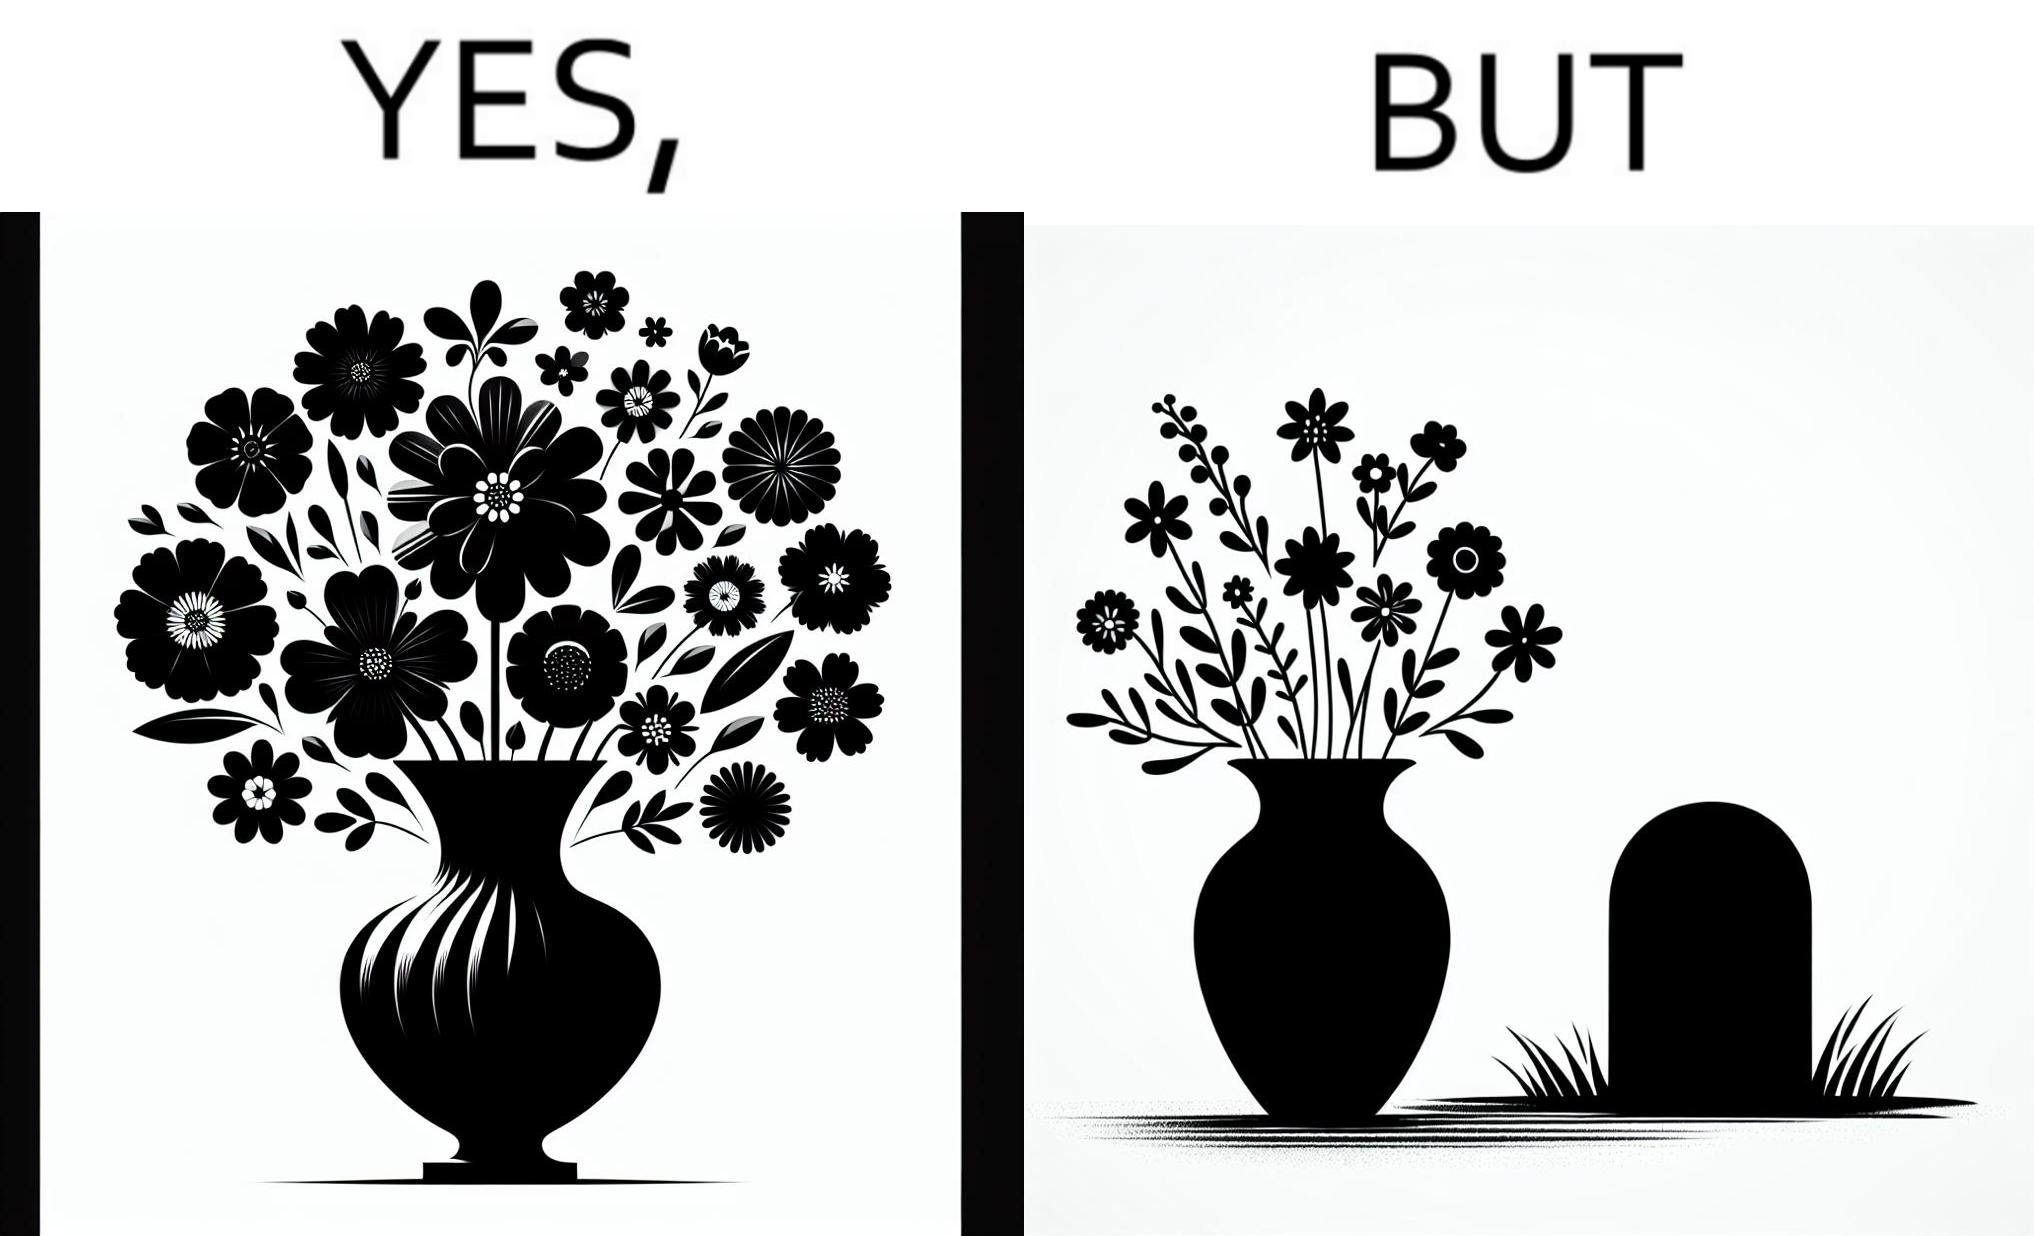Would you classify this image as satirical? Yes, this image is satirical. 